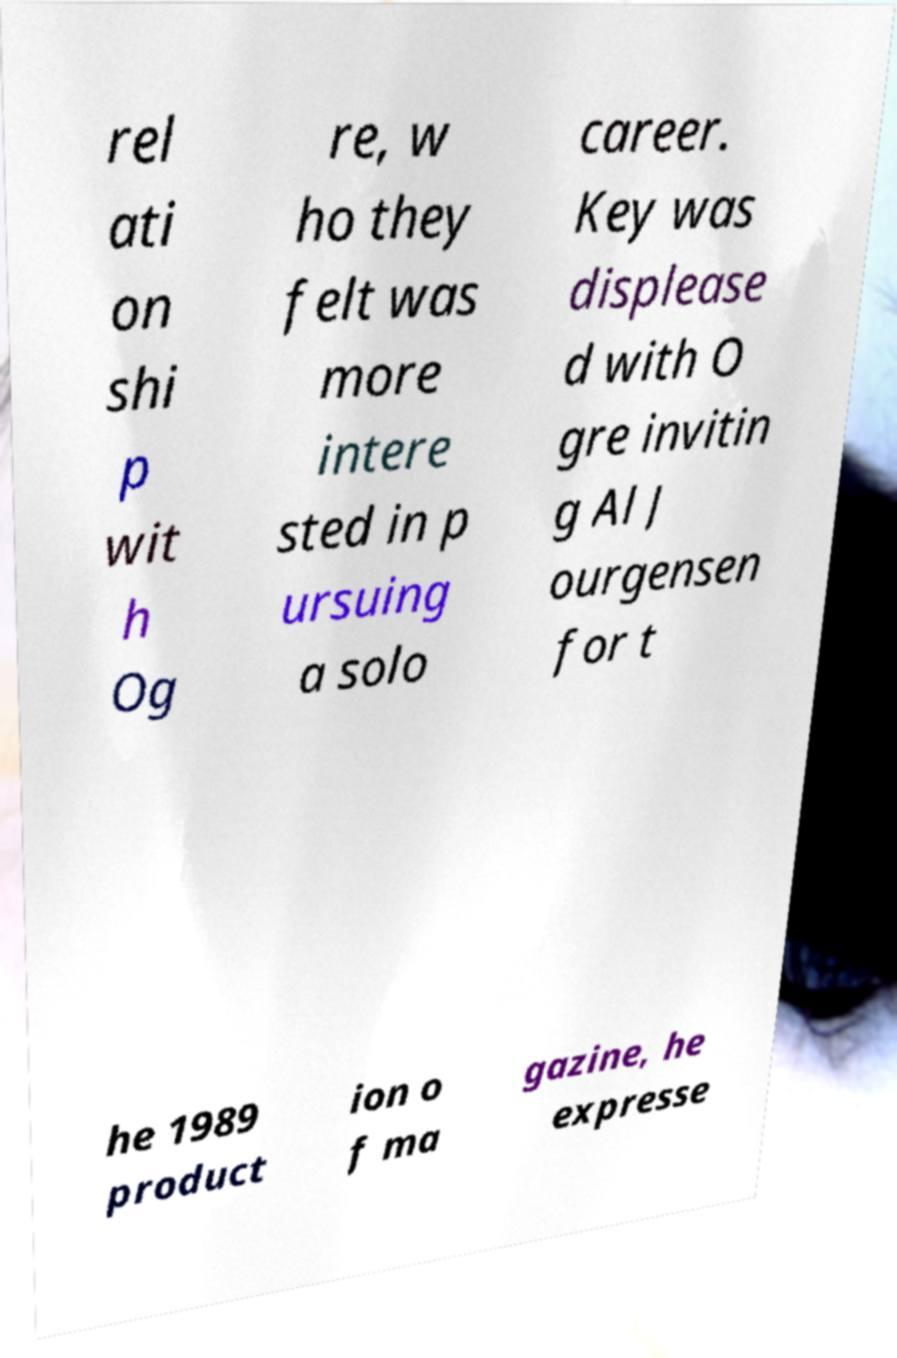For documentation purposes, I need the text within this image transcribed. Could you provide that? rel ati on shi p wit h Og re, w ho they felt was more intere sted in p ursuing a solo career. Key was displease d with O gre invitin g Al J ourgensen for t he 1989 product ion o f ma gazine, he expresse 